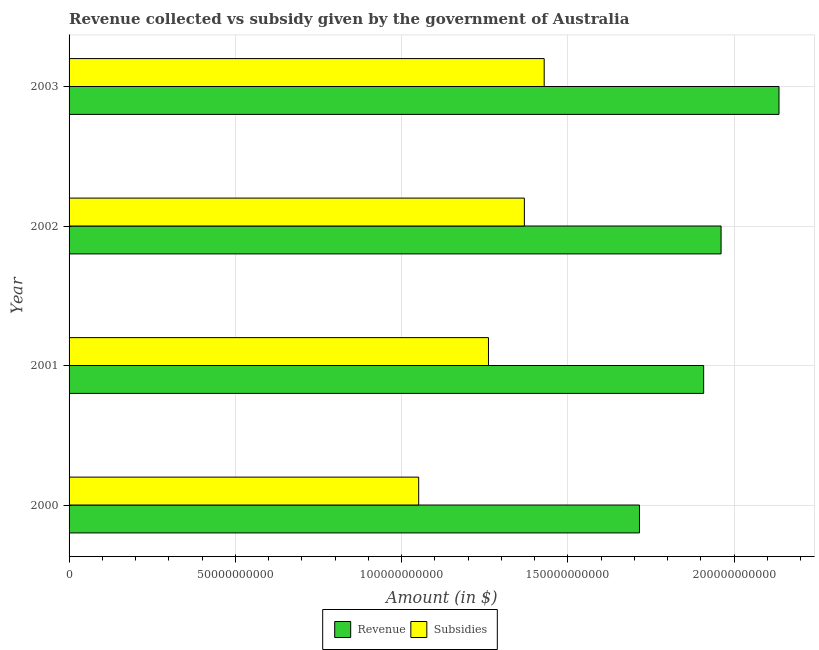Are the number of bars on each tick of the Y-axis equal?
Keep it short and to the point. Yes. What is the label of the 2nd group of bars from the top?
Keep it short and to the point. 2002. What is the amount of subsidies given in 2000?
Ensure brevity in your answer.  1.05e+11. Across all years, what is the maximum amount of subsidies given?
Your answer should be very brief. 1.43e+11. Across all years, what is the minimum amount of subsidies given?
Make the answer very short. 1.05e+11. In which year was the amount of revenue collected maximum?
Give a very brief answer. 2003. What is the total amount of revenue collected in the graph?
Offer a terse response. 7.72e+11. What is the difference between the amount of revenue collected in 2000 and that in 2002?
Your response must be concise. -2.45e+1. What is the difference between the amount of subsidies given in 2003 and the amount of revenue collected in 2001?
Give a very brief answer. -4.80e+1. What is the average amount of subsidies given per year?
Make the answer very short. 1.28e+11. In the year 2003, what is the difference between the amount of revenue collected and amount of subsidies given?
Offer a terse response. 7.06e+1. In how many years, is the amount of subsidies given greater than 90000000000 $?
Give a very brief answer. 4. What is the ratio of the amount of subsidies given in 2002 to that in 2003?
Provide a succinct answer. 0.96. Is the amount of revenue collected in 2002 less than that in 2003?
Ensure brevity in your answer.  Yes. What is the difference between the highest and the second highest amount of revenue collected?
Your answer should be compact. 1.74e+1. What is the difference between the highest and the lowest amount of revenue collected?
Your response must be concise. 4.20e+1. In how many years, is the amount of subsidies given greater than the average amount of subsidies given taken over all years?
Provide a short and direct response. 2. Is the sum of the amount of subsidies given in 2001 and 2003 greater than the maximum amount of revenue collected across all years?
Keep it short and to the point. Yes. What does the 1st bar from the top in 2003 represents?
Make the answer very short. Subsidies. What does the 1st bar from the bottom in 2001 represents?
Provide a short and direct response. Revenue. How many bars are there?
Your answer should be very brief. 8. How many legend labels are there?
Keep it short and to the point. 2. What is the title of the graph?
Offer a terse response. Revenue collected vs subsidy given by the government of Australia. Does "Female population" appear as one of the legend labels in the graph?
Offer a very short reply. No. What is the label or title of the X-axis?
Your response must be concise. Amount (in $). What is the Amount (in $) in Revenue in 2000?
Your answer should be compact. 1.72e+11. What is the Amount (in $) of Subsidies in 2000?
Your response must be concise. 1.05e+11. What is the Amount (in $) of Revenue in 2001?
Provide a succinct answer. 1.91e+11. What is the Amount (in $) of Subsidies in 2001?
Give a very brief answer. 1.26e+11. What is the Amount (in $) of Revenue in 2002?
Offer a very short reply. 1.96e+11. What is the Amount (in $) in Subsidies in 2002?
Your answer should be compact. 1.37e+11. What is the Amount (in $) in Revenue in 2003?
Your response must be concise. 2.13e+11. What is the Amount (in $) of Subsidies in 2003?
Ensure brevity in your answer.  1.43e+11. Across all years, what is the maximum Amount (in $) of Revenue?
Offer a terse response. 2.13e+11. Across all years, what is the maximum Amount (in $) in Subsidies?
Make the answer very short. 1.43e+11. Across all years, what is the minimum Amount (in $) in Revenue?
Provide a succinct answer. 1.72e+11. Across all years, what is the minimum Amount (in $) in Subsidies?
Your response must be concise. 1.05e+11. What is the total Amount (in $) of Revenue in the graph?
Offer a terse response. 7.72e+11. What is the total Amount (in $) of Subsidies in the graph?
Make the answer very short. 5.11e+11. What is the difference between the Amount (in $) in Revenue in 2000 and that in 2001?
Your response must be concise. -1.93e+1. What is the difference between the Amount (in $) in Subsidies in 2000 and that in 2001?
Offer a very short reply. -2.10e+1. What is the difference between the Amount (in $) in Revenue in 2000 and that in 2002?
Ensure brevity in your answer.  -2.45e+1. What is the difference between the Amount (in $) in Subsidies in 2000 and that in 2002?
Your answer should be very brief. -3.18e+1. What is the difference between the Amount (in $) of Revenue in 2000 and that in 2003?
Ensure brevity in your answer.  -4.20e+1. What is the difference between the Amount (in $) in Subsidies in 2000 and that in 2003?
Make the answer very short. -3.77e+1. What is the difference between the Amount (in $) of Revenue in 2001 and that in 2002?
Your response must be concise. -5.24e+09. What is the difference between the Amount (in $) of Subsidies in 2001 and that in 2002?
Offer a terse response. -1.08e+1. What is the difference between the Amount (in $) in Revenue in 2001 and that in 2003?
Offer a terse response. -2.27e+1. What is the difference between the Amount (in $) in Subsidies in 2001 and that in 2003?
Make the answer very short. -1.68e+1. What is the difference between the Amount (in $) in Revenue in 2002 and that in 2003?
Keep it short and to the point. -1.74e+1. What is the difference between the Amount (in $) of Subsidies in 2002 and that in 2003?
Provide a succinct answer. -5.96e+09. What is the difference between the Amount (in $) in Revenue in 2000 and the Amount (in $) in Subsidies in 2001?
Provide a short and direct response. 4.54e+1. What is the difference between the Amount (in $) in Revenue in 2000 and the Amount (in $) in Subsidies in 2002?
Your answer should be compact. 3.46e+1. What is the difference between the Amount (in $) in Revenue in 2000 and the Amount (in $) in Subsidies in 2003?
Give a very brief answer. 2.87e+1. What is the difference between the Amount (in $) in Revenue in 2001 and the Amount (in $) in Subsidies in 2002?
Offer a very short reply. 5.39e+1. What is the difference between the Amount (in $) in Revenue in 2001 and the Amount (in $) in Subsidies in 2003?
Offer a terse response. 4.80e+1. What is the difference between the Amount (in $) of Revenue in 2002 and the Amount (in $) of Subsidies in 2003?
Make the answer very short. 5.32e+1. What is the average Amount (in $) in Revenue per year?
Your answer should be compact. 1.93e+11. What is the average Amount (in $) of Subsidies per year?
Provide a short and direct response. 1.28e+11. In the year 2000, what is the difference between the Amount (in $) of Revenue and Amount (in $) of Subsidies?
Your answer should be very brief. 6.64e+1. In the year 2001, what is the difference between the Amount (in $) in Revenue and Amount (in $) in Subsidies?
Your answer should be very brief. 6.47e+1. In the year 2002, what is the difference between the Amount (in $) in Revenue and Amount (in $) in Subsidies?
Provide a short and direct response. 5.91e+1. In the year 2003, what is the difference between the Amount (in $) in Revenue and Amount (in $) in Subsidies?
Give a very brief answer. 7.06e+1. What is the ratio of the Amount (in $) of Revenue in 2000 to that in 2001?
Give a very brief answer. 0.9. What is the ratio of the Amount (in $) of Subsidies in 2000 to that in 2001?
Offer a very short reply. 0.83. What is the ratio of the Amount (in $) of Revenue in 2000 to that in 2002?
Your answer should be compact. 0.87. What is the ratio of the Amount (in $) of Subsidies in 2000 to that in 2002?
Your response must be concise. 0.77. What is the ratio of the Amount (in $) in Revenue in 2000 to that in 2003?
Provide a succinct answer. 0.8. What is the ratio of the Amount (in $) in Subsidies in 2000 to that in 2003?
Your answer should be compact. 0.74. What is the ratio of the Amount (in $) of Revenue in 2001 to that in 2002?
Ensure brevity in your answer.  0.97. What is the ratio of the Amount (in $) of Subsidies in 2001 to that in 2002?
Provide a succinct answer. 0.92. What is the ratio of the Amount (in $) of Revenue in 2001 to that in 2003?
Provide a succinct answer. 0.89. What is the ratio of the Amount (in $) of Subsidies in 2001 to that in 2003?
Offer a very short reply. 0.88. What is the ratio of the Amount (in $) in Revenue in 2002 to that in 2003?
Give a very brief answer. 0.92. What is the ratio of the Amount (in $) in Subsidies in 2002 to that in 2003?
Offer a terse response. 0.96. What is the difference between the highest and the second highest Amount (in $) in Revenue?
Ensure brevity in your answer.  1.74e+1. What is the difference between the highest and the second highest Amount (in $) of Subsidies?
Provide a short and direct response. 5.96e+09. What is the difference between the highest and the lowest Amount (in $) in Revenue?
Make the answer very short. 4.20e+1. What is the difference between the highest and the lowest Amount (in $) in Subsidies?
Offer a terse response. 3.77e+1. 